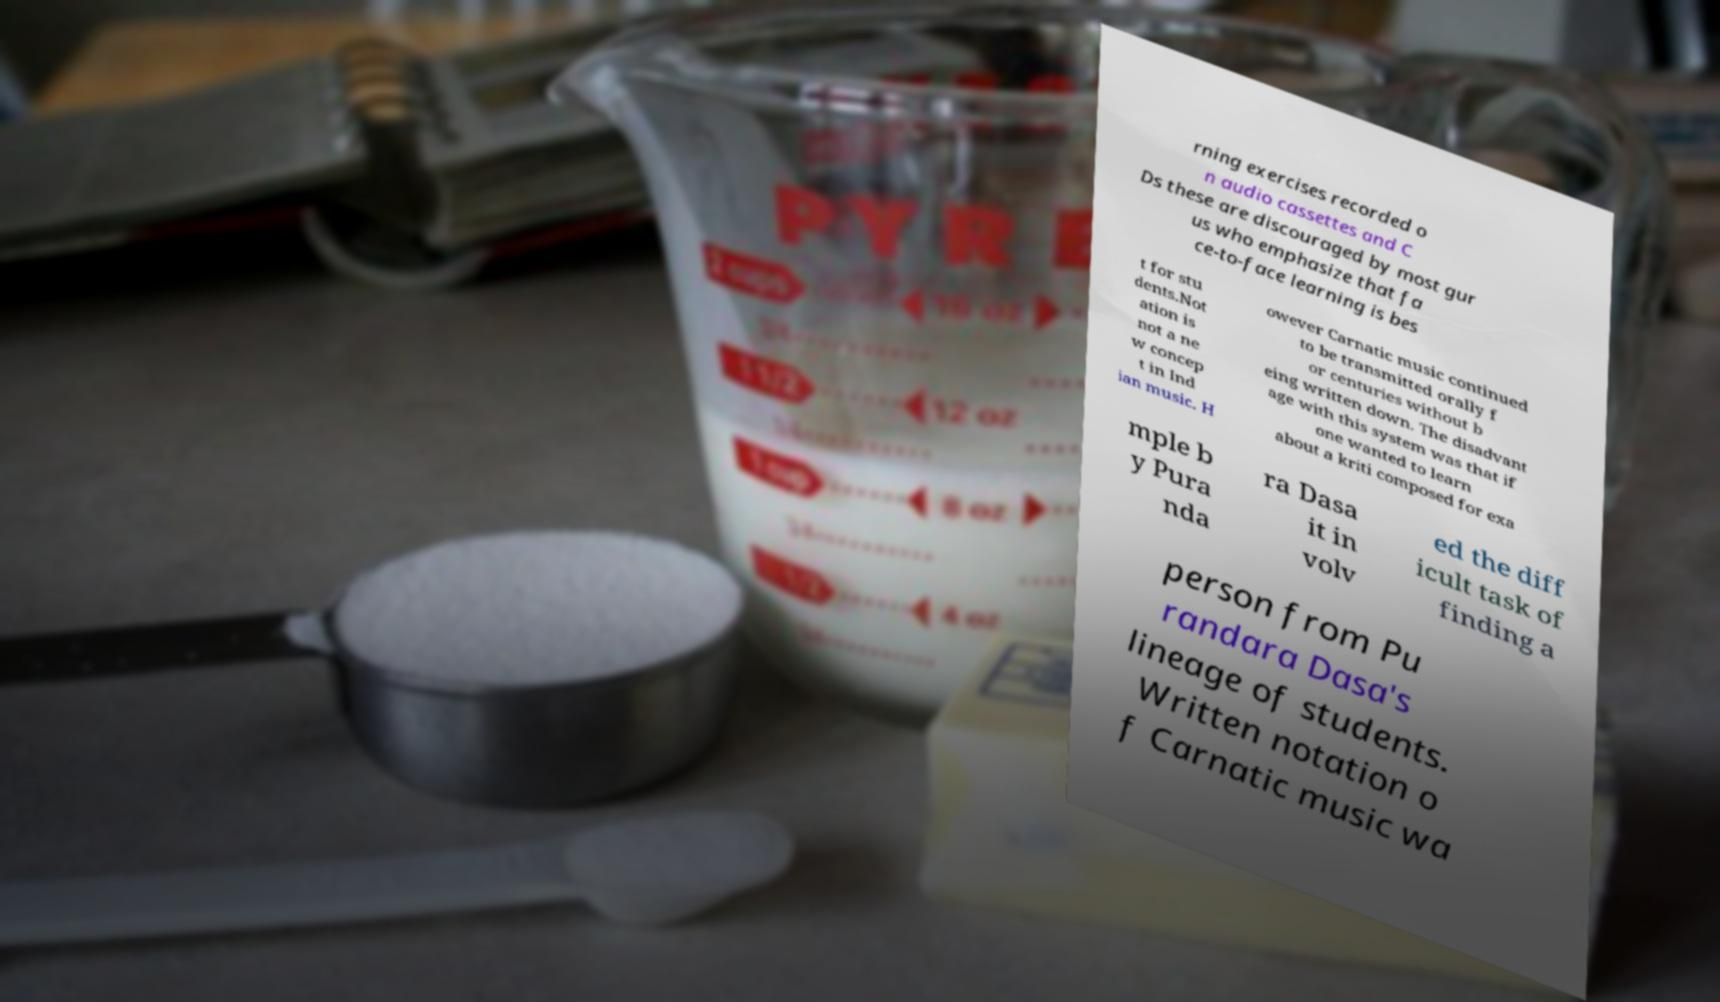Could you assist in decoding the text presented in this image and type it out clearly? rning exercises recorded o n audio cassettes and C Ds these are discouraged by most gur us who emphasize that fa ce-to-face learning is bes t for stu dents.Not ation is not a ne w concep t in Ind ian music. H owever Carnatic music continued to be transmitted orally f or centuries without b eing written down. The disadvant age with this system was that if one wanted to learn about a kriti composed for exa mple b y Pura nda ra Dasa it in volv ed the diff icult task of finding a person from Pu randara Dasa's lineage of students. Written notation o f Carnatic music wa 